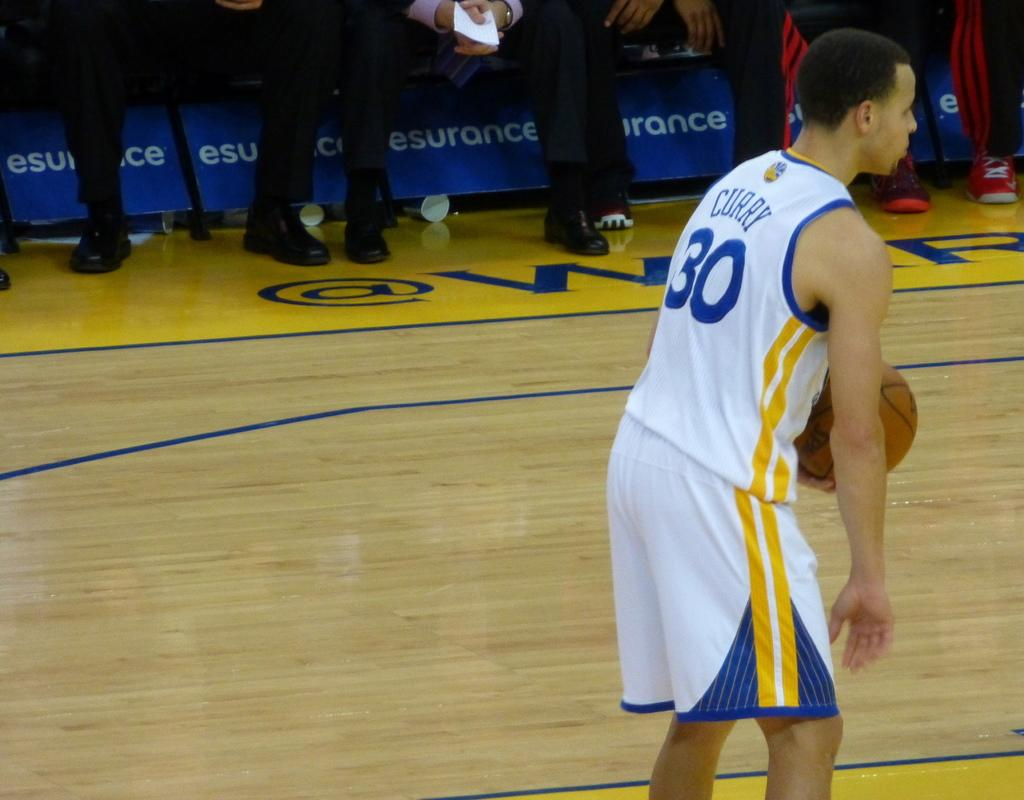Provide a one-sentence caption for the provided image. A basketball player named Curry wears the number 30 uniform. 